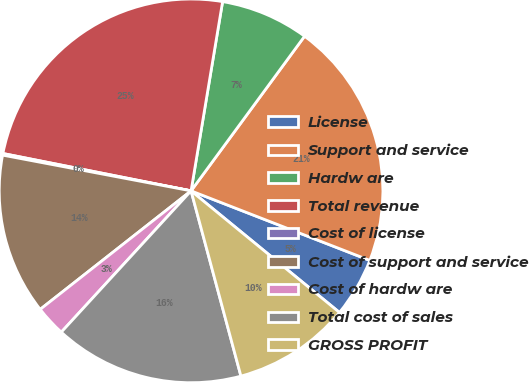<chart> <loc_0><loc_0><loc_500><loc_500><pie_chart><fcel>License<fcel>Support and service<fcel>Hardw are<fcel>Total revenue<fcel>Cost of license<fcel>Cost of support and service<fcel>Cost of hardw are<fcel>Total cost of sales<fcel>GROSS PROFIT<nl><fcel>5.02%<fcel>20.83%<fcel>7.45%<fcel>24.51%<fcel>0.14%<fcel>13.58%<fcel>2.58%<fcel>16.01%<fcel>9.89%<nl></chart> 